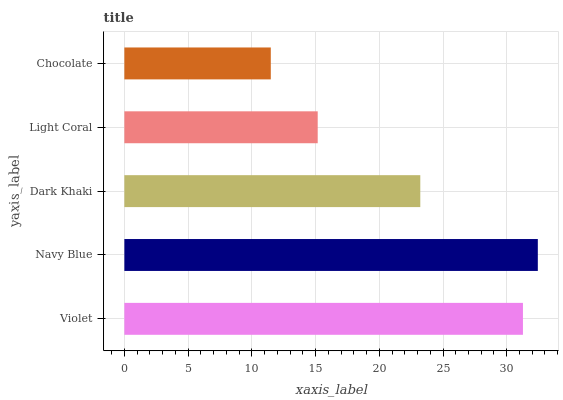Is Chocolate the minimum?
Answer yes or no. Yes. Is Navy Blue the maximum?
Answer yes or no. Yes. Is Dark Khaki the minimum?
Answer yes or no. No. Is Dark Khaki the maximum?
Answer yes or no. No. Is Navy Blue greater than Dark Khaki?
Answer yes or no. Yes. Is Dark Khaki less than Navy Blue?
Answer yes or no. Yes. Is Dark Khaki greater than Navy Blue?
Answer yes or no. No. Is Navy Blue less than Dark Khaki?
Answer yes or no. No. Is Dark Khaki the high median?
Answer yes or no. Yes. Is Dark Khaki the low median?
Answer yes or no. Yes. Is Navy Blue the high median?
Answer yes or no. No. Is Chocolate the low median?
Answer yes or no. No. 